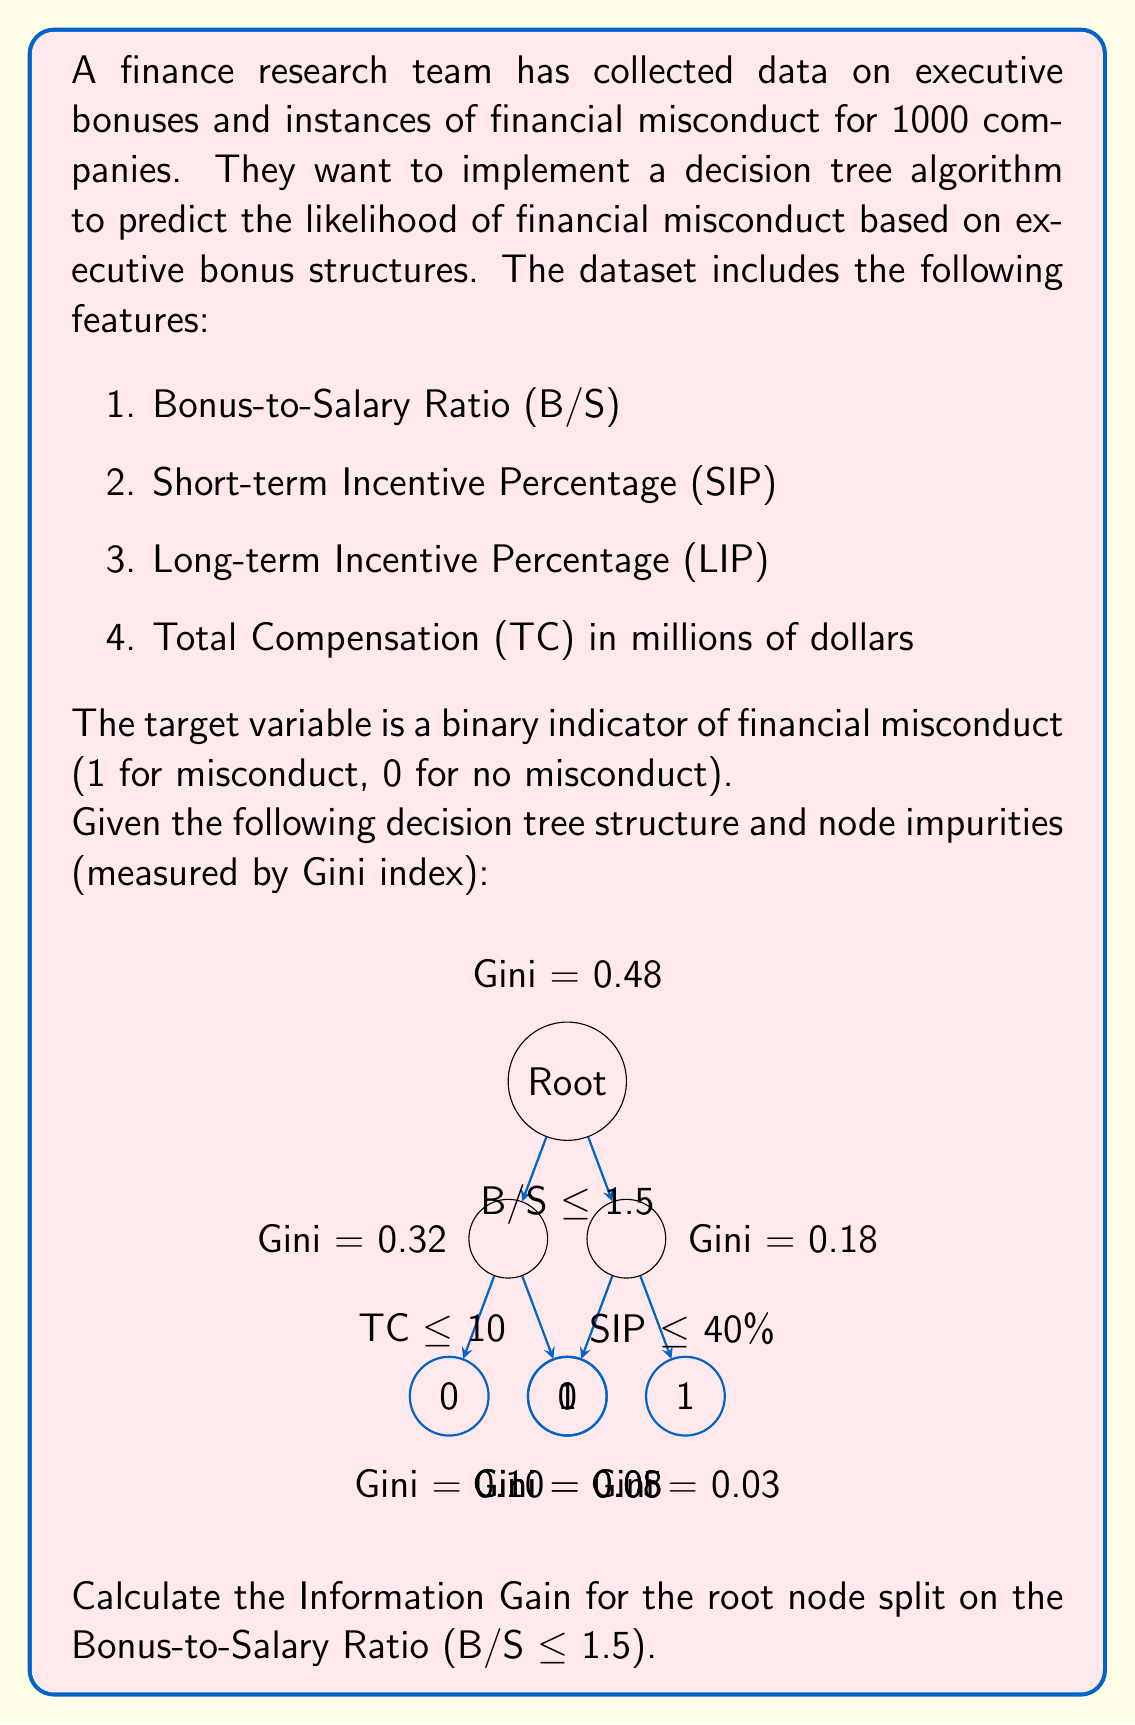Show me your answer to this math problem. To calculate the Information Gain for the root node split, we need to use the following formula:

$$ IG = Gini_{parent} - \sum_{i=1}^{n} \frac{N_i}{N} \cdot Gini_i $$

Where:
- $IG$ is the Information Gain
- $Gini_{parent}$ is the Gini impurity of the parent node
- $N_i$ is the number of samples in the $i$-th child node
- $N$ is the total number of samples
- $Gini_i$ is the Gini impurity of the $i$-th child node

Step 1: Identify the Gini impurities
- Parent node (Root): Gini = 0.48
- Left child node (B/S ≤ 1.5): Gini = 0.32
- Right child node (B/S > 1.5): Gini = 0.18

Step 2: Calculate the proportion of samples in each child node
We don't have the exact number of samples in each node, but we can use the Gini impurities to estimate the proportions. A lower Gini impurity suggests a larger sample size. Let's assume:
- Left child: 60% of samples
- Right child: 40% of samples

Step 3: Apply the Information Gain formula
$$ IG = 0.48 - (0.6 \cdot 0.32 + 0.4 \cdot 0.18) $$
$$ IG = 0.48 - (0.192 + 0.072) $$
$$ IG = 0.48 - 0.264 $$
$$ IG = 0.216 $$

Therefore, the Information Gain for the root node split on Bonus-to-Salary Ratio (B/S ≤ 1.5) is 0.216.
Answer: 0.216 